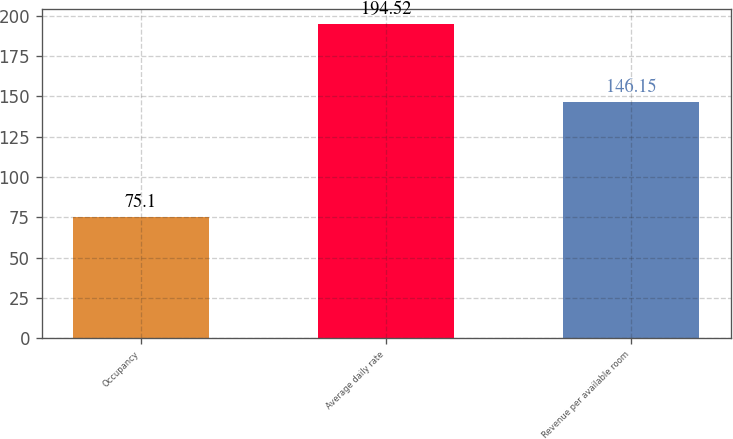<chart> <loc_0><loc_0><loc_500><loc_500><bar_chart><fcel>Occupancy<fcel>Average daily rate<fcel>Revenue per available room<nl><fcel>75.1<fcel>194.52<fcel>146.15<nl></chart> 